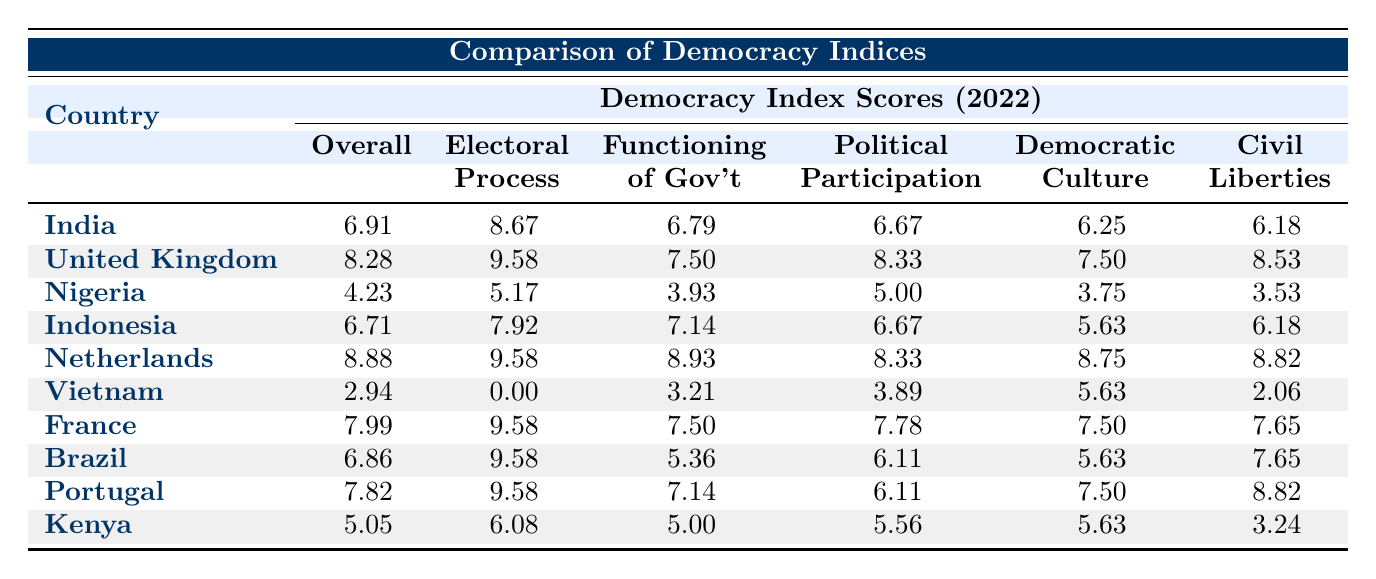What is the Democracy Index Score for India in 2022? The Democracy Index Score for India is located in the row corresponding to India, which shows a score of 6.91 for the year 2022.
Answer: 6.91 Which country has the highest Civil Liberties Score? By inspecting the scores in the Civil Liberties column, the Netherlands has the highest Civil Liberties Score of 8.82.
Answer: 8.82 What is the difference in the overall Democracy Index Score between Nigeria and Kenya? The Democracy Index Score for Nigeria is 4.23, while for Kenya it is 5.05. The difference is calculated as 5.05 - 4.23 = 0.82.
Answer: 0.82 Does Vietnam have a higher Political Participation Score than Nigeria? The Political Participation Score for Vietnam is 3.89 and for Nigeria, it is 5.00. Since 3.89 is less than 5.00, the statement is false.
Answer: No What is the average Electoral Process Score of the post-colonial nations listed? The Electoral Process Scores are 8.67 (India), 5.17 (Nigeria), 7.92 (Indonesia), 6.08 (Kenya). Sum: 8.67 + 5.17 + 7.92 + 6.08 = 27.84. There are 4 countries, so average is 27.84 / 4 = 6.96.
Answer: 6.96 Which former colonizer has the best overall Democracy Index Score? The former colonizers are the United Kingdom, Netherlands, France, and Portugal. Their scores are 8.28, 8.88, 7.99, and 7.82 respectively. The highest score is for the Netherlands at 8.88.
Answer: Netherlands What is the lowest score for the Functioning of Government among post-colonial nations? The Functioning of Government Scores are as follows: India (6.79), Nigeria (3.93), Indonesia (7.14), Kenya (5.00), with the lowest being Nigeria at 3.93.
Answer: 3.93 Is India's Democratic Culture Score higher than Vietnam's? The Democratic Culture Score for India is 6.25 and for Vietnam, it is 5.63. Since 6.25 is greater than 5.63, the statement is true.
Answer: Yes 